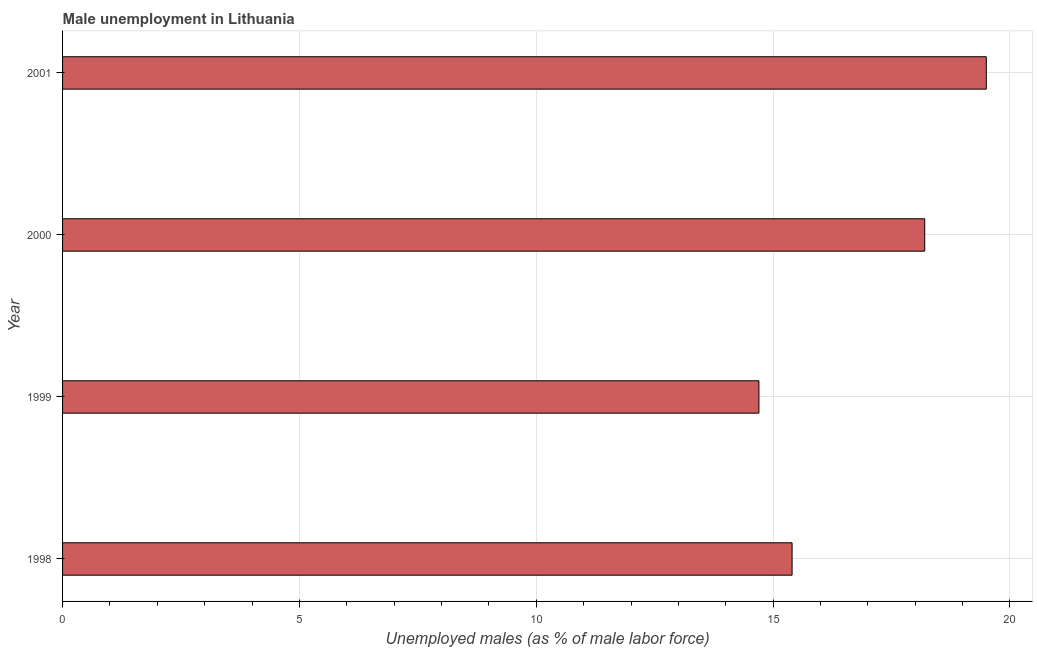Does the graph contain grids?
Keep it short and to the point. Yes. What is the title of the graph?
Offer a terse response. Male unemployment in Lithuania. What is the label or title of the X-axis?
Give a very brief answer. Unemployed males (as % of male labor force). What is the label or title of the Y-axis?
Your answer should be compact. Year. What is the unemployed males population in 2000?
Offer a terse response. 18.2. Across all years, what is the maximum unemployed males population?
Your response must be concise. 19.5. Across all years, what is the minimum unemployed males population?
Offer a terse response. 14.7. In which year was the unemployed males population maximum?
Your response must be concise. 2001. What is the sum of the unemployed males population?
Your answer should be very brief. 67.8. What is the average unemployed males population per year?
Give a very brief answer. 16.95. What is the median unemployed males population?
Provide a succinct answer. 16.8. In how many years, is the unemployed males population greater than 8 %?
Your response must be concise. 4. What is the ratio of the unemployed males population in 1998 to that in 2000?
Your answer should be very brief. 0.85. Is the unemployed males population in 1998 less than that in 2000?
Make the answer very short. Yes. Is the sum of the unemployed males population in 2000 and 2001 greater than the maximum unemployed males population across all years?
Your answer should be very brief. Yes. What is the difference between the highest and the lowest unemployed males population?
Provide a short and direct response. 4.8. In how many years, is the unemployed males population greater than the average unemployed males population taken over all years?
Provide a short and direct response. 2. Are all the bars in the graph horizontal?
Your answer should be very brief. Yes. How many years are there in the graph?
Offer a very short reply. 4. What is the Unemployed males (as % of male labor force) in 1998?
Keep it short and to the point. 15.4. What is the Unemployed males (as % of male labor force) of 1999?
Provide a succinct answer. 14.7. What is the Unemployed males (as % of male labor force) in 2000?
Your response must be concise. 18.2. What is the difference between the Unemployed males (as % of male labor force) in 1998 and 2000?
Your answer should be compact. -2.8. What is the difference between the Unemployed males (as % of male labor force) in 2000 and 2001?
Your answer should be compact. -1.3. What is the ratio of the Unemployed males (as % of male labor force) in 1998 to that in 1999?
Offer a terse response. 1.05. What is the ratio of the Unemployed males (as % of male labor force) in 1998 to that in 2000?
Ensure brevity in your answer.  0.85. What is the ratio of the Unemployed males (as % of male labor force) in 1998 to that in 2001?
Give a very brief answer. 0.79. What is the ratio of the Unemployed males (as % of male labor force) in 1999 to that in 2000?
Keep it short and to the point. 0.81. What is the ratio of the Unemployed males (as % of male labor force) in 1999 to that in 2001?
Ensure brevity in your answer.  0.75. What is the ratio of the Unemployed males (as % of male labor force) in 2000 to that in 2001?
Offer a terse response. 0.93. 